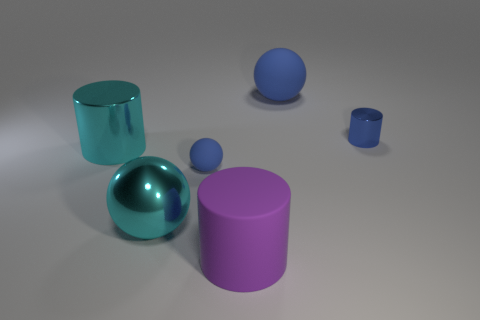Add 1 small brown rubber cylinders. How many objects exist? 7 Subtract all gray cylinders. Subtract all small blue shiny objects. How many objects are left? 5 Add 5 big cyan shiny spheres. How many big cyan shiny spheres are left? 6 Add 2 blue shiny cylinders. How many blue shiny cylinders exist? 3 Subtract 1 cyan spheres. How many objects are left? 5 